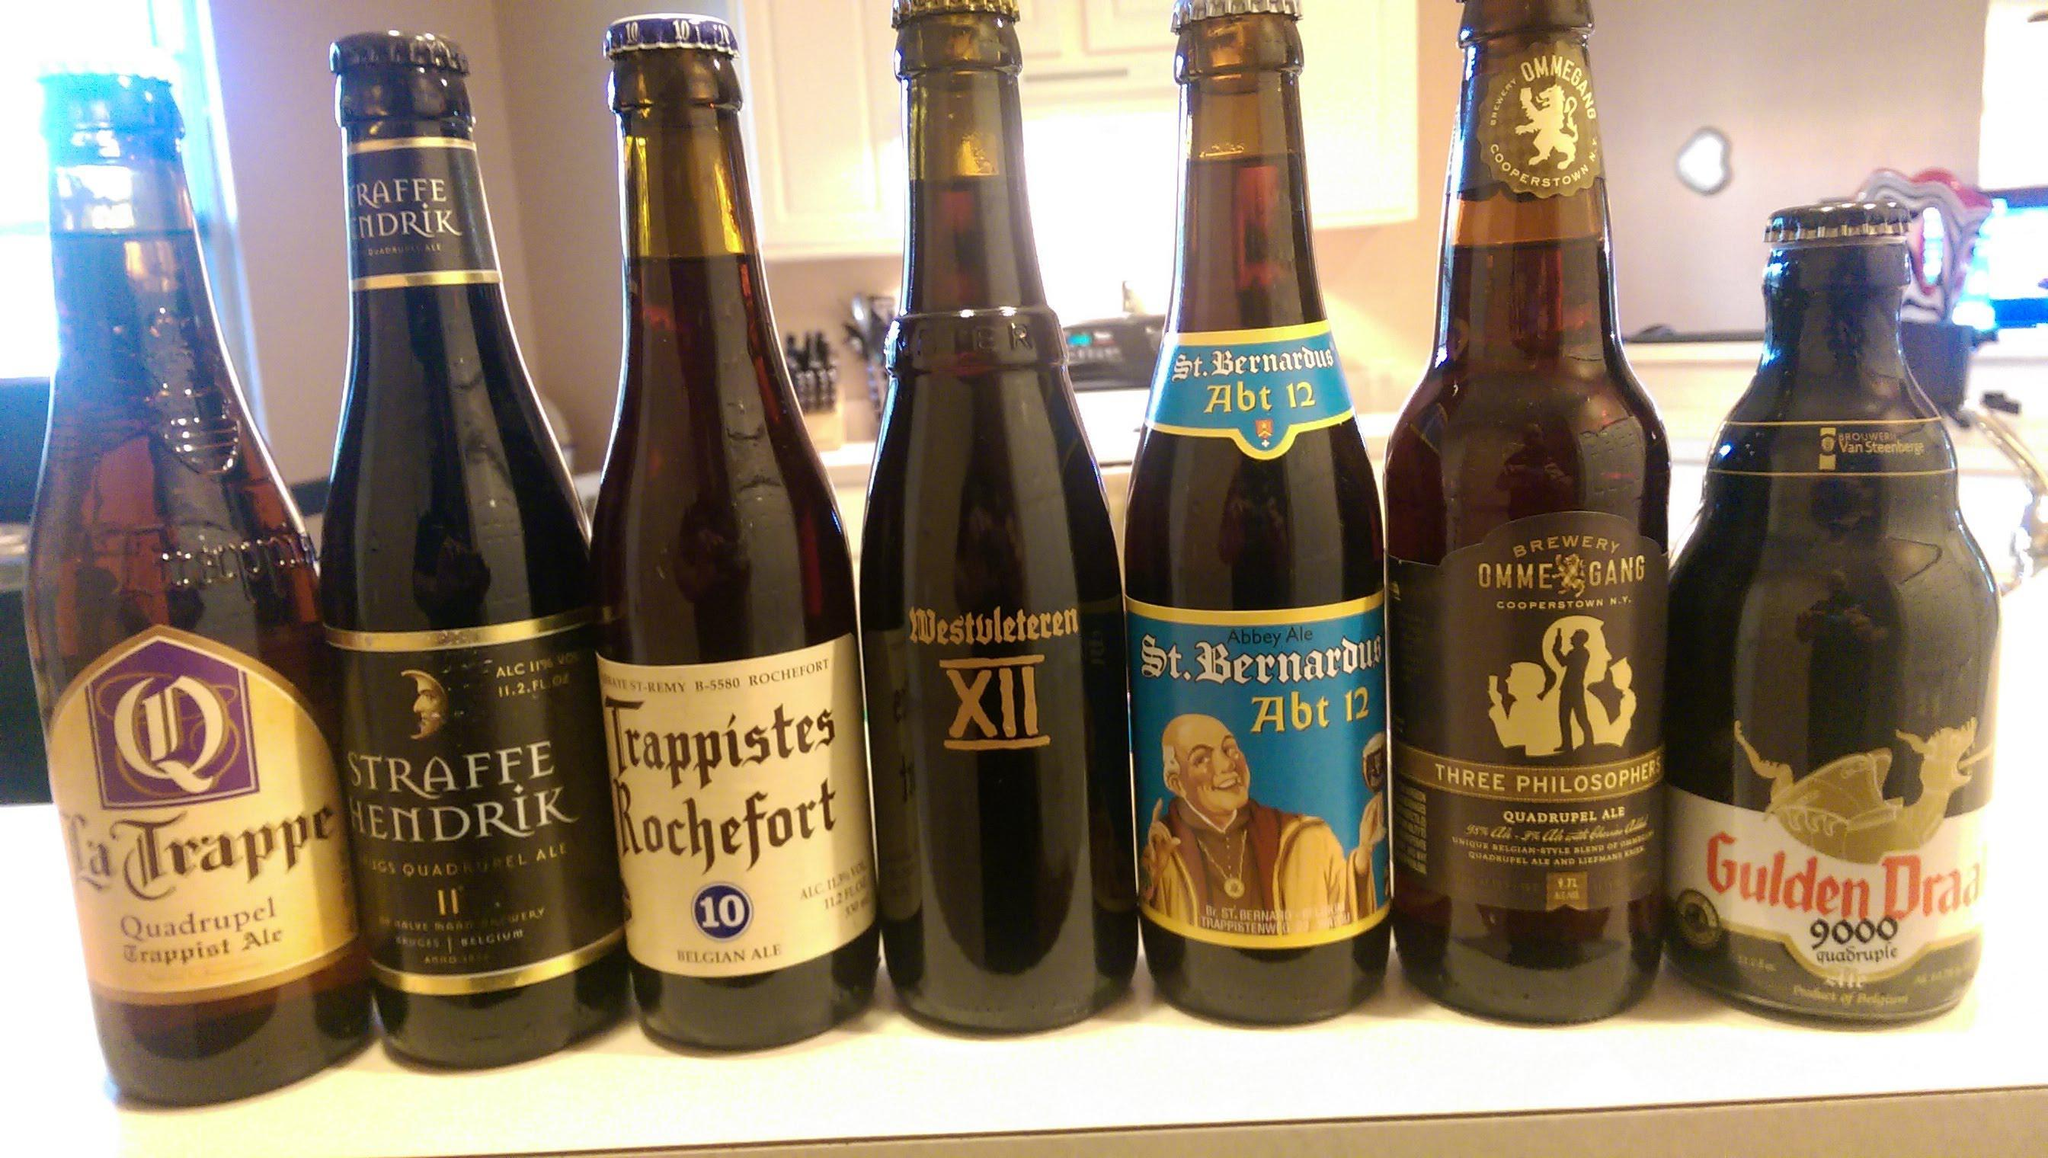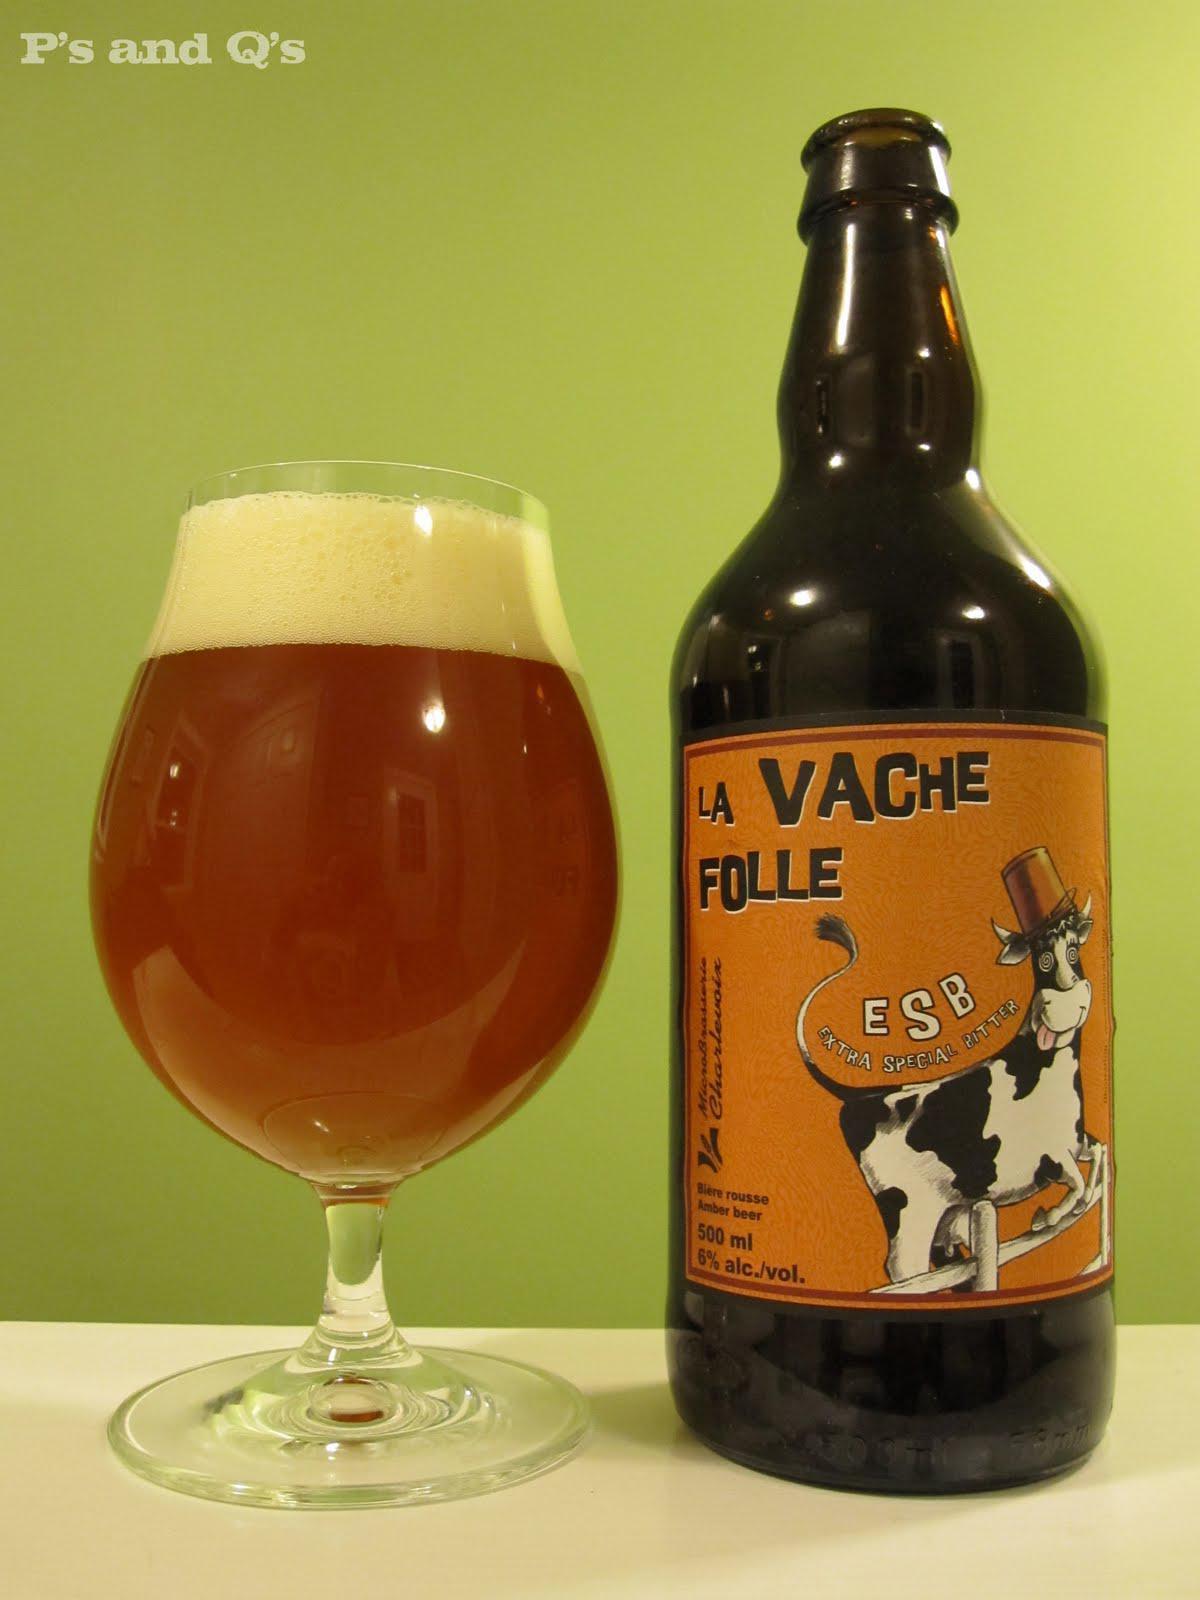The first image is the image on the left, the second image is the image on the right. Evaluate the accuracy of this statement regarding the images: "There are more bottles in the image on the right.". Is it true? Answer yes or no. No. The first image is the image on the left, the second image is the image on the right. For the images displayed, is the sentence "There is only one bottle in at least one of the images." factually correct? Answer yes or no. Yes. 